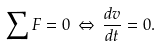Convert formula to latex. <formula><loc_0><loc_0><loc_500><loc_500>\sum F = 0 \, \Leftrightarrow \, { \frac { d v } { d t } } = 0 .</formula> 